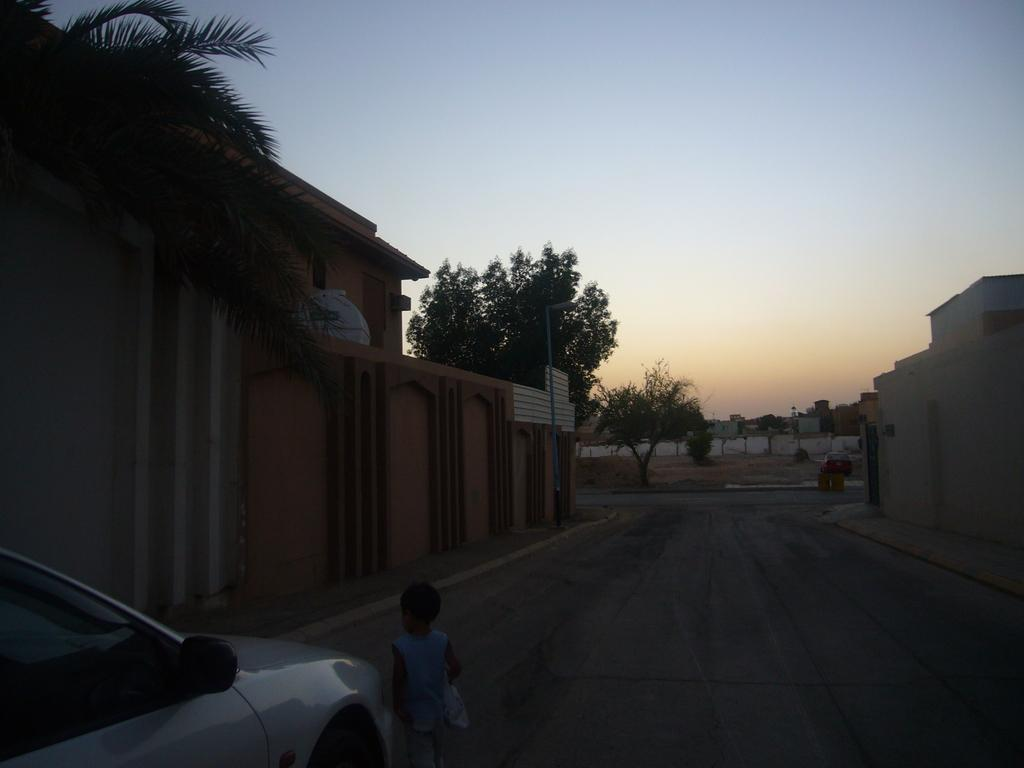What is on the road in the image? There is a car on the road in the image. What is the girl doing in the image? The girl is standing in the image. What type of building can be seen in the image? There is a house in the image. What type of vegetation is present in the image? There are trees in the image. What is visible above the ground in the image? The sky is visible in the image. How many mice are hiding behind the car in the image? There are no mice present in the image; it features a car on the road, a standing girl, a house, trees, and a visible sky. What type of lumber is being used to construct the house in the image? The image does not provide information about the materials used to construct the house; it only shows that there is a house in the image. 